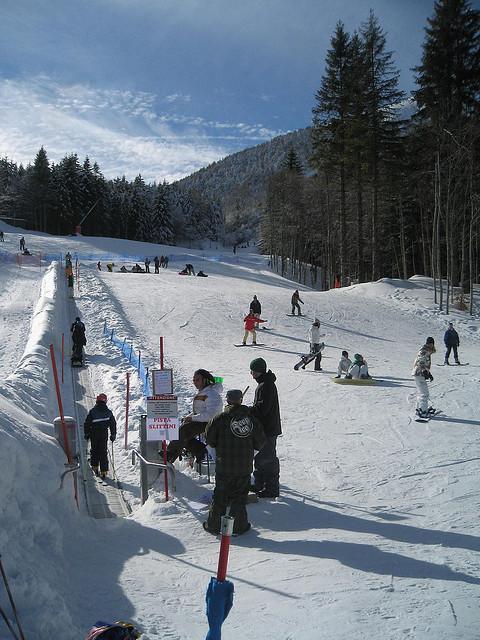Is the little boy skiing on his own?
Be succinct. No. Is the child adorable?
Answer briefly. Yes. What sport is being performed here?
Quick response, please. Snowboarding. Overcast or sunny?
Give a very brief answer. Sunny. Is there a snowman on the ground?
Keep it brief. No. 